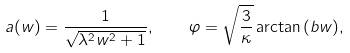<formula> <loc_0><loc_0><loc_500><loc_500>a ( w ) = \frac { 1 } { \sqrt { \lambda ^ { 2 } w ^ { 2 } + 1 } } , \quad \varphi = \sqrt { \frac { 3 } { \kappa } } \arctan { ( b w ) } ,</formula> 